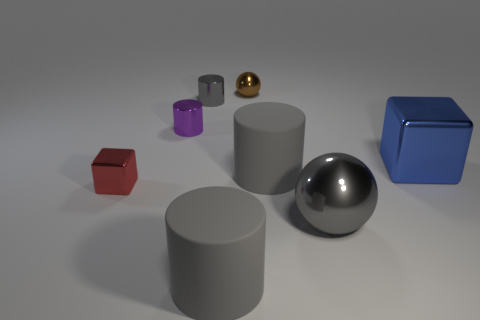Do the purple metallic thing and the gray metallic cylinder have the same size?
Ensure brevity in your answer.  Yes. The metallic object that is on the right side of the tiny gray shiny object and in front of the large cube is what color?
Offer a very short reply. Gray. The big cylinder that is behind the shiny block that is in front of the large blue shiny cube is made of what material?
Your answer should be compact. Rubber. There is a blue thing that is the same shape as the tiny red object; what is its size?
Your answer should be compact. Large. There is a large rubber cylinder that is behind the small red metallic block; does it have the same color as the big ball?
Your answer should be very brief. Yes. Are there fewer large brown rubber cubes than tiny brown things?
Give a very brief answer. Yes. How many other objects are the same color as the large shiny ball?
Provide a short and direct response. 3. Do the large gray cylinder that is behind the red thing and the red object have the same material?
Your response must be concise. No. What is the material of the block that is to the right of the small brown metal sphere?
Make the answer very short. Metal. There is a rubber object that is to the right of the large gray rubber object left of the small metal sphere; how big is it?
Provide a succinct answer. Large. 